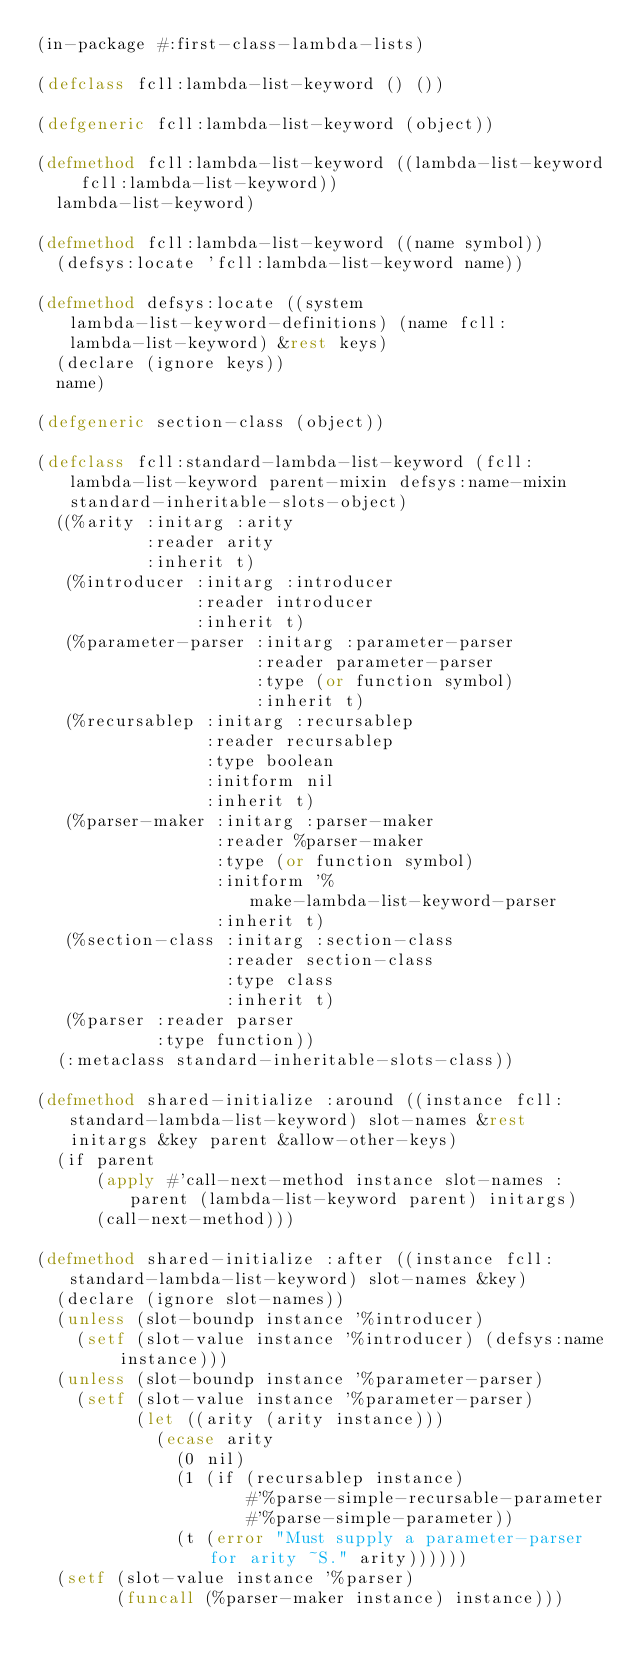<code> <loc_0><loc_0><loc_500><loc_500><_Lisp_>(in-package #:first-class-lambda-lists)

(defclass fcll:lambda-list-keyword () ())

(defgeneric fcll:lambda-list-keyword (object))

(defmethod fcll:lambda-list-keyword ((lambda-list-keyword fcll:lambda-list-keyword))
  lambda-list-keyword)

(defmethod fcll:lambda-list-keyword ((name symbol))
  (defsys:locate 'fcll:lambda-list-keyword name))

(defmethod defsys:locate ((system lambda-list-keyword-definitions) (name fcll:lambda-list-keyword) &rest keys)
  (declare (ignore keys))
  name)

(defgeneric section-class (object))

(defclass fcll:standard-lambda-list-keyword (fcll:lambda-list-keyword parent-mixin defsys:name-mixin standard-inheritable-slots-object)
  ((%arity :initarg :arity
           :reader arity
           :inherit t)
   (%introducer :initarg :introducer
                :reader introducer
                :inherit t)
   (%parameter-parser :initarg :parameter-parser
                      :reader parameter-parser
                      :type (or function symbol)
                      :inherit t)
   (%recursablep :initarg :recursablep
                 :reader recursablep
                 :type boolean
                 :initform nil
                 :inherit t)
   (%parser-maker :initarg :parser-maker
                  :reader %parser-maker
                  :type (or function symbol)
                  :initform '%make-lambda-list-keyword-parser
                  :inherit t)
   (%section-class :initarg :section-class
                   :reader section-class
                   :type class
                   :inherit t)
   (%parser :reader parser
            :type function))
  (:metaclass standard-inheritable-slots-class))

(defmethod shared-initialize :around ((instance fcll:standard-lambda-list-keyword) slot-names &rest initargs &key parent &allow-other-keys)
  (if parent
      (apply #'call-next-method instance slot-names :parent (lambda-list-keyword parent) initargs)
      (call-next-method)))

(defmethod shared-initialize :after ((instance fcll:standard-lambda-list-keyword) slot-names &key)
  (declare (ignore slot-names))
  (unless (slot-boundp instance '%introducer)
    (setf (slot-value instance '%introducer) (defsys:name instance)))
  (unless (slot-boundp instance '%parameter-parser)
    (setf (slot-value instance '%parameter-parser)
          (let ((arity (arity instance)))
            (ecase arity
              (0 nil)
              (1 (if (recursablep instance)
                     #'%parse-simple-recursable-parameter
                     #'%parse-simple-parameter))
              (t (error "Must supply a parameter-parser for arity ~S." arity))))))
  (setf (slot-value instance '%parser)
        (funcall (%parser-maker instance) instance)))
</code> 